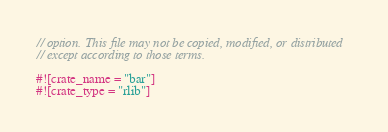Convert code to text. <code><loc_0><loc_0><loc_500><loc_500><_Rust_>// option. This file may not be copied, modified, or distributed
// except according to those terms.

#![crate_name = "bar"]
#![crate_type = "rlib"]
</code> 